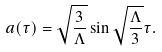Convert formula to latex. <formula><loc_0><loc_0><loc_500><loc_500>a ( \tau ) = \sqrt { \frac { 3 } { \Lambda } } \sin \sqrt { \frac { \Lambda } { 3 } } \tau .</formula> 